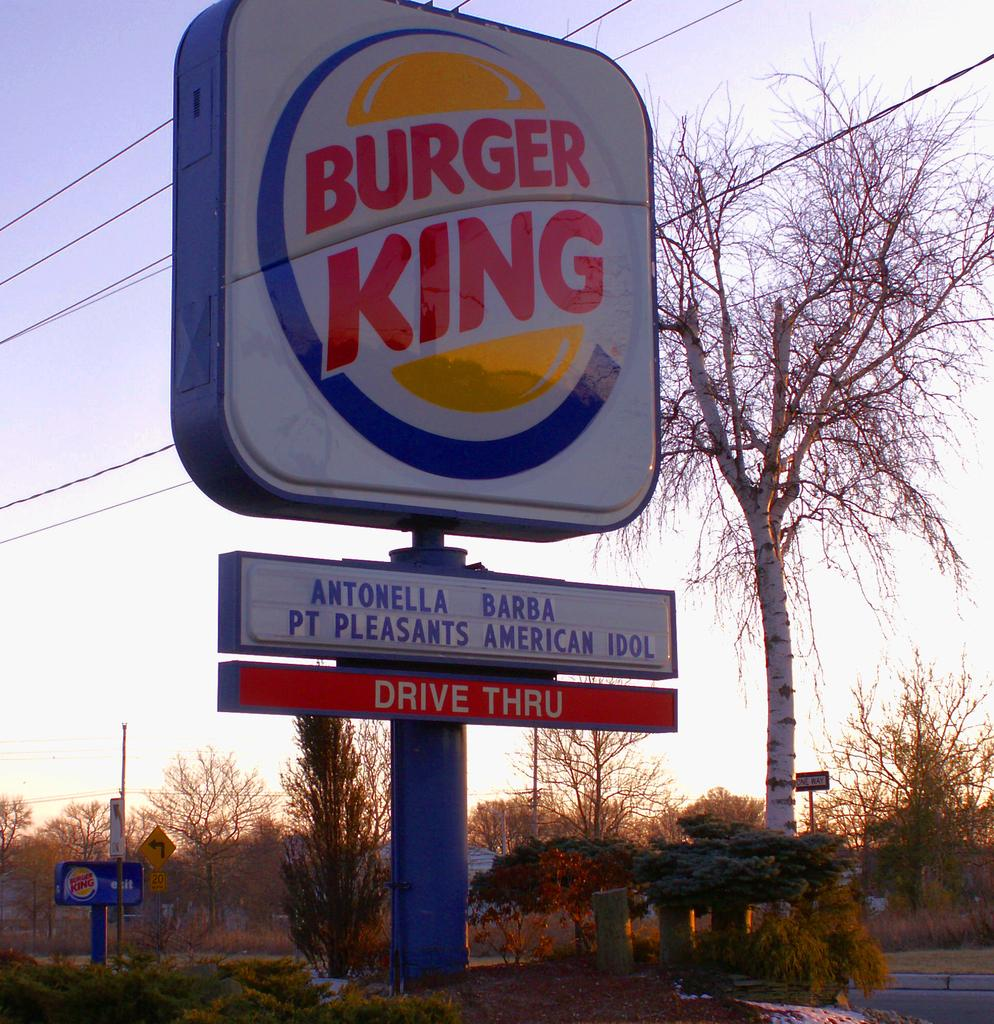<image>
Give a short and clear explanation of the subsequent image. A large sign for a Burger King on a cloudy day. 